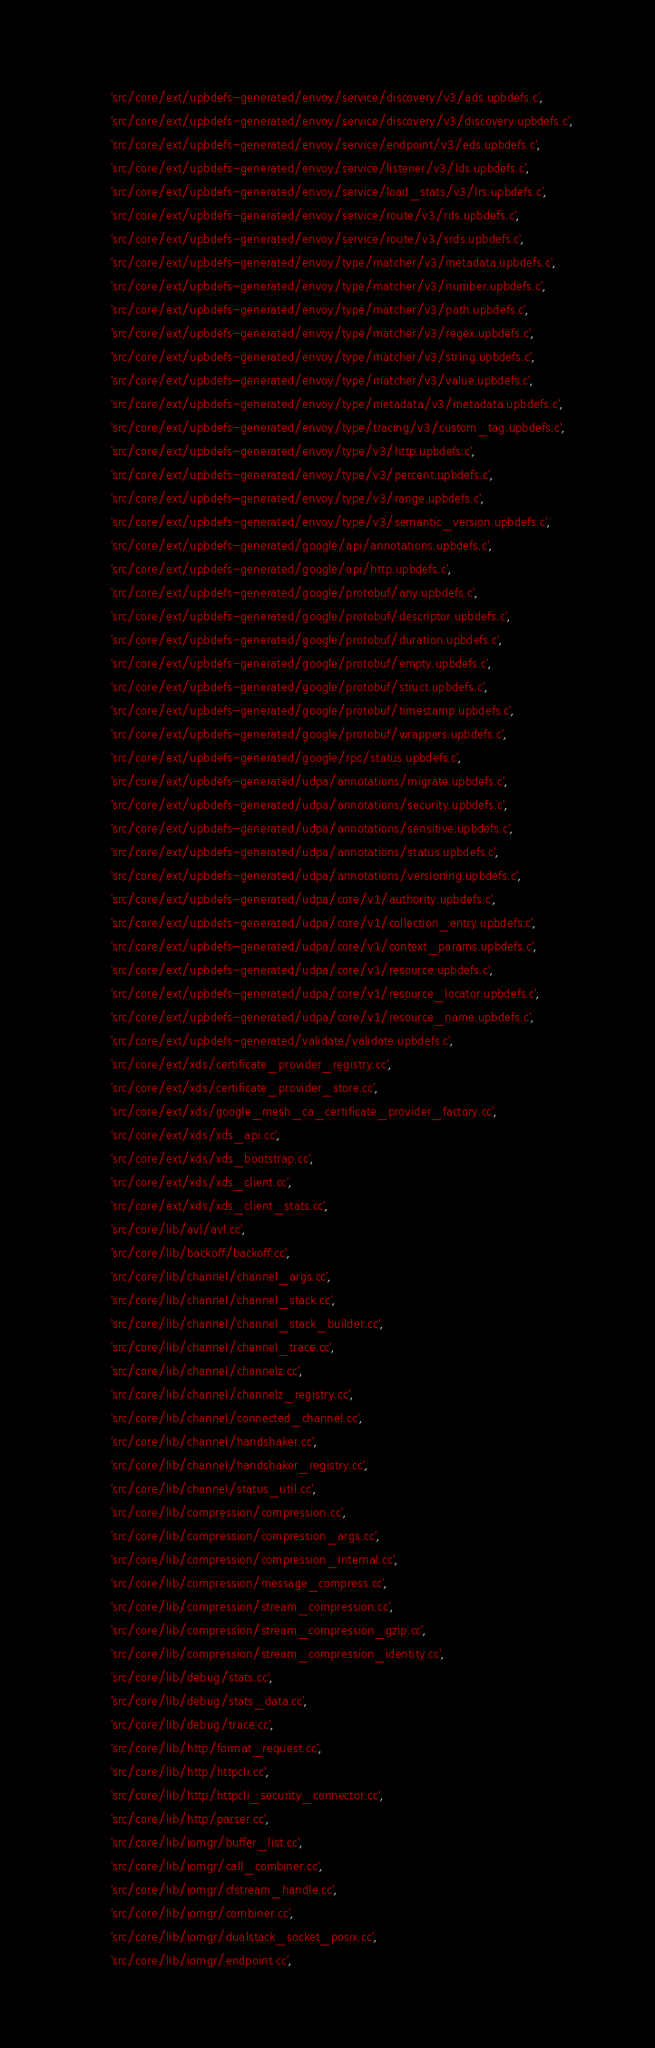<code> <loc_0><loc_0><loc_500><loc_500><_Python_>        'src/core/ext/upbdefs-generated/envoy/service/discovery/v3/ads.upbdefs.c',
        'src/core/ext/upbdefs-generated/envoy/service/discovery/v3/discovery.upbdefs.c',
        'src/core/ext/upbdefs-generated/envoy/service/endpoint/v3/eds.upbdefs.c',
        'src/core/ext/upbdefs-generated/envoy/service/listener/v3/lds.upbdefs.c',
        'src/core/ext/upbdefs-generated/envoy/service/load_stats/v3/lrs.upbdefs.c',
        'src/core/ext/upbdefs-generated/envoy/service/route/v3/rds.upbdefs.c',
        'src/core/ext/upbdefs-generated/envoy/service/route/v3/srds.upbdefs.c',
        'src/core/ext/upbdefs-generated/envoy/type/matcher/v3/metadata.upbdefs.c',
        'src/core/ext/upbdefs-generated/envoy/type/matcher/v3/number.upbdefs.c',
        'src/core/ext/upbdefs-generated/envoy/type/matcher/v3/path.upbdefs.c',
        'src/core/ext/upbdefs-generated/envoy/type/matcher/v3/regex.upbdefs.c',
        'src/core/ext/upbdefs-generated/envoy/type/matcher/v3/string.upbdefs.c',
        'src/core/ext/upbdefs-generated/envoy/type/matcher/v3/value.upbdefs.c',
        'src/core/ext/upbdefs-generated/envoy/type/metadata/v3/metadata.upbdefs.c',
        'src/core/ext/upbdefs-generated/envoy/type/tracing/v3/custom_tag.upbdefs.c',
        'src/core/ext/upbdefs-generated/envoy/type/v3/http.upbdefs.c',
        'src/core/ext/upbdefs-generated/envoy/type/v3/percent.upbdefs.c',
        'src/core/ext/upbdefs-generated/envoy/type/v3/range.upbdefs.c',
        'src/core/ext/upbdefs-generated/envoy/type/v3/semantic_version.upbdefs.c',
        'src/core/ext/upbdefs-generated/google/api/annotations.upbdefs.c',
        'src/core/ext/upbdefs-generated/google/api/http.upbdefs.c',
        'src/core/ext/upbdefs-generated/google/protobuf/any.upbdefs.c',
        'src/core/ext/upbdefs-generated/google/protobuf/descriptor.upbdefs.c',
        'src/core/ext/upbdefs-generated/google/protobuf/duration.upbdefs.c',
        'src/core/ext/upbdefs-generated/google/protobuf/empty.upbdefs.c',
        'src/core/ext/upbdefs-generated/google/protobuf/struct.upbdefs.c',
        'src/core/ext/upbdefs-generated/google/protobuf/timestamp.upbdefs.c',
        'src/core/ext/upbdefs-generated/google/protobuf/wrappers.upbdefs.c',
        'src/core/ext/upbdefs-generated/google/rpc/status.upbdefs.c',
        'src/core/ext/upbdefs-generated/udpa/annotations/migrate.upbdefs.c',
        'src/core/ext/upbdefs-generated/udpa/annotations/security.upbdefs.c',
        'src/core/ext/upbdefs-generated/udpa/annotations/sensitive.upbdefs.c',
        'src/core/ext/upbdefs-generated/udpa/annotations/status.upbdefs.c',
        'src/core/ext/upbdefs-generated/udpa/annotations/versioning.upbdefs.c',
        'src/core/ext/upbdefs-generated/udpa/core/v1/authority.upbdefs.c',
        'src/core/ext/upbdefs-generated/udpa/core/v1/collection_entry.upbdefs.c',
        'src/core/ext/upbdefs-generated/udpa/core/v1/context_params.upbdefs.c',
        'src/core/ext/upbdefs-generated/udpa/core/v1/resource.upbdefs.c',
        'src/core/ext/upbdefs-generated/udpa/core/v1/resource_locator.upbdefs.c',
        'src/core/ext/upbdefs-generated/udpa/core/v1/resource_name.upbdefs.c',
        'src/core/ext/upbdefs-generated/validate/validate.upbdefs.c',
        'src/core/ext/xds/certificate_provider_registry.cc',
        'src/core/ext/xds/certificate_provider_store.cc',
        'src/core/ext/xds/google_mesh_ca_certificate_provider_factory.cc',
        'src/core/ext/xds/xds_api.cc',
        'src/core/ext/xds/xds_bootstrap.cc',
        'src/core/ext/xds/xds_client.cc',
        'src/core/ext/xds/xds_client_stats.cc',
        'src/core/lib/avl/avl.cc',
        'src/core/lib/backoff/backoff.cc',
        'src/core/lib/channel/channel_args.cc',
        'src/core/lib/channel/channel_stack.cc',
        'src/core/lib/channel/channel_stack_builder.cc',
        'src/core/lib/channel/channel_trace.cc',
        'src/core/lib/channel/channelz.cc',
        'src/core/lib/channel/channelz_registry.cc',
        'src/core/lib/channel/connected_channel.cc',
        'src/core/lib/channel/handshaker.cc',
        'src/core/lib/channel/handshaker_registry.cc',
        'src/core/lib/channel/status_util.cc',
        'src/core/lib/compression/compression.cc',
        'src/core/lib/compression/compression_args.cc',
        'src/core/lib/compression/compression_internal.cc',
        'src/core/lib/compression/message_compress.cc',
        'src/core/lib/compression/stream_compression.cc',
        'src/core/lib/compression/stream_compression_gzip.cc',
        'src/core/lib/compression/stream_compression_identity.cc',
        'src/core/lib/debug/stats.cc',
        'src/core/lib/debug/stats_data.cc',
        'src/core/lib/debug/trace.cc',
        'src/core/lib/http/format_request.cc',
        'src/core/lib/http/httpcli.cc',
        'src/core/lib/http/httpcli_security_connector.cc',
        'src/core/lib/http/parser.cc',
        'src/core/lib/iomgr/buffer_list.cc',
        'src/core/lib/iomgr/call_combiner.cc',
        'src/core/lib/iomgr/cfstream_handle.cc',
        'src/core/lib/iomgr/combiner.cc',
        'src/core/lib/iomgr/dualstack_socket_posix.cc',
        'src/core/lib/iomgr/endpoint.cc',</code> 